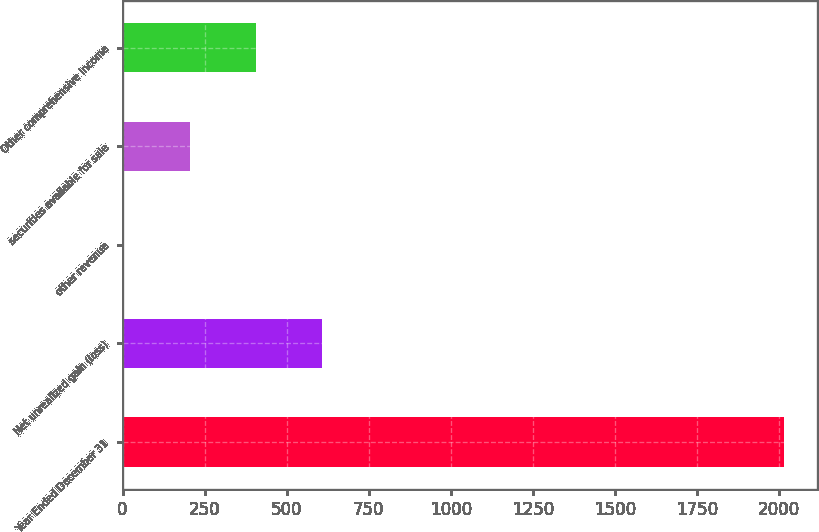Convert chart. <chart><loc_0><loc_0><loc_500><loc_500><bar_chart><fcel>Year Ended December 31<fcel>Net unrealized gain (loss)<fcel>other revenue<fcel>securities available for sale<fcel>Other comprehensive income<nl><fcel>2014<fcel>607<fcel>4<fcel>205<fcel>406<nl></chart> 